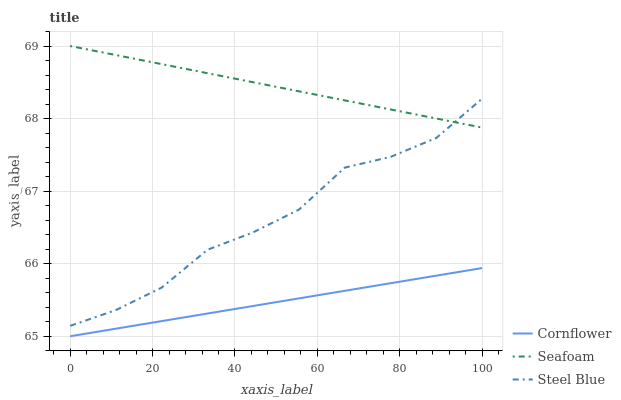Does Cornflower have the minimum area under the curve?
Answer yes or no. Yes. Does Seafoam have the maximum area under the curve?
Answer yes or no. Yes. Does Steel Blue have the minimum area under the curve?
Answer yes or no. No. Does Steel Blue have the maximum area under the curve?
Answer yes or no. No. Is Cornflower the smoothest?
Answer yes or no. Yes. Is Steel Blue the roughest?
Answer yes or no. Yes. Is Seafoam the smoothest?
Answer yes or no. No. Is Seafoam the roughest?
Answer yes or no. No. Does Cornflower have the lowest value?
Answer yes or no. Yes. Does Steel Blue have the lowest value?
Answer yes or no. No. Does Seafoam have the highest value?
Answer yes or no. Yes. Does Steel Blue have the highest value?
Answer yes or no. No. Is Cornflower less than Seafoam?
Answer yes or no. Yes. Is Steel Blue greater than Cornflower?
Answer yes or no. Yes. Does Seafoam intersect Steel Blue?
Answer yes or no. Yes. Is Seafoam less than Steel Blue?
Answer yes or no. No. Is Seafoam greater than Steel Blue?
Answer yes or no. No. Does Cornflower intersect Seafoam?
Answer yes or no. No. 